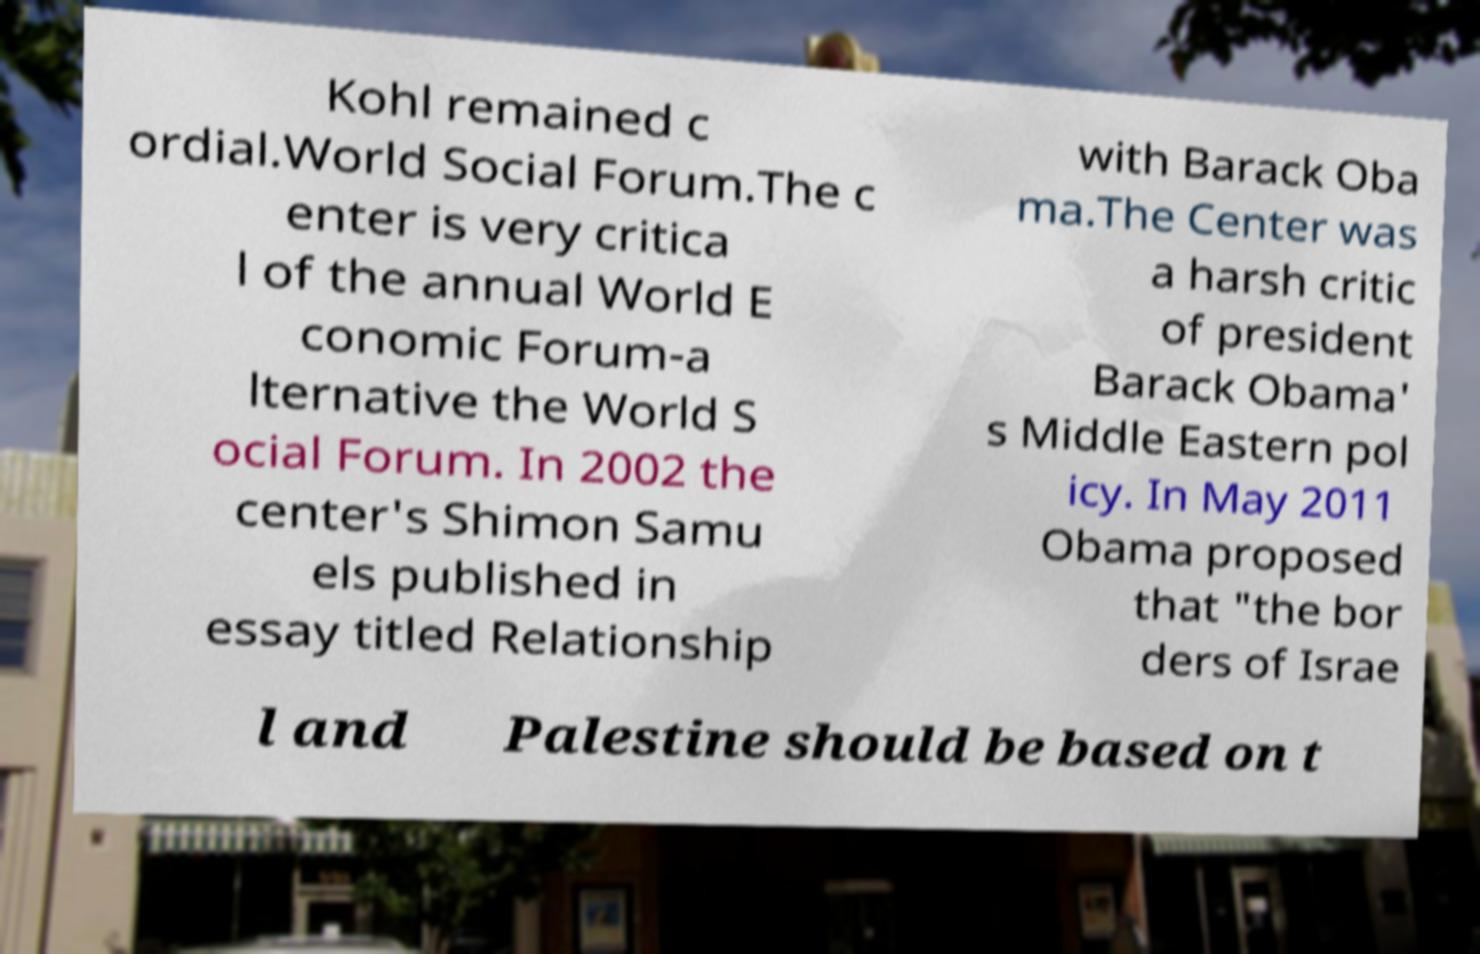Could you extract and type out the text from this image? Kohl remained c ordial.World Social Forum.The c enter is very critica l of the annual World E conomic Forum-a lternative the World S ocial Forum. In 2002 the center's Shimon Samu els published in essay titled Relationship with Barack Oba ma.The Center was a harsh critic of president Barack Obama' s Middle Eastern pol icy. In May 2011 Obama proposed that "the bor ders of Israe l and Palestine should be based on t 